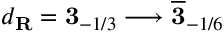Convert formula to latex. <formula><loc_0><loc_0><loc_500><loc_500>d _ { R } = { 3 } _ { - 1 / 3 } \longrightarrow \overline { 3 } _ { - 1 / 6 }</formula> 